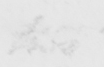Please transcribe the handwritten text in this image. two 